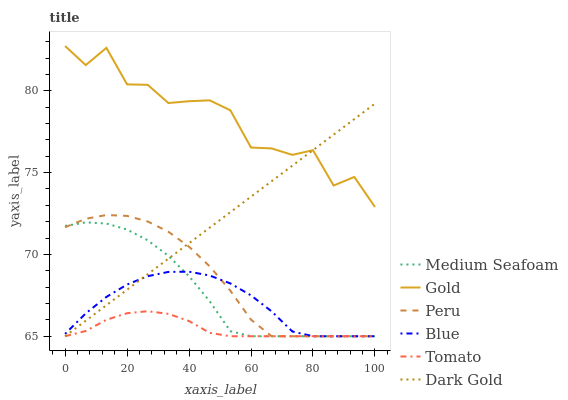Does Tomato have the minimum area under the curve?
Answer yes or no. Yes. Does Gold have the maximum area under the curve?
Answer yes or no. Yes. Does Gold have the minimum area under the curve?
Answer yes or no. No. Does Tomato have the maximum area under the curve?
Answer yes or no. No. Is Dark Gold the smoothest?
Answer yes or no. Yes. Is Gold the roughest?
Answer yes or no. Yes. Is Tomato the smoothest?
Answer yes or no. No. Is Tomato the roughest?
Answer yes or no. No. Does Blue have the lowest value?
Answer yes or no. Yes. Does Gold have the lowest value?
Answer yes or no. No. Does Gold have the highest value?
Answer yes or no. Yes. Does Tomato have the highest value?
Answer yes or no. No. Is Medium Seafoam less than Gold?
Answer yes or no. Yes. Is Gold greater than Peru?
Answer yes or no. Yes. Does Dark Gold intersect Medium Seafoam?
Answer yes or no. Yes. Is Dark Gold less than Medium Seafoam?
Answer yes or no. No. Is Dark Gold greater than Medium Seafoam?
Answer yes or no. No. Does Medium Seafoam intersect Gold?
Answer yes or no. No. 